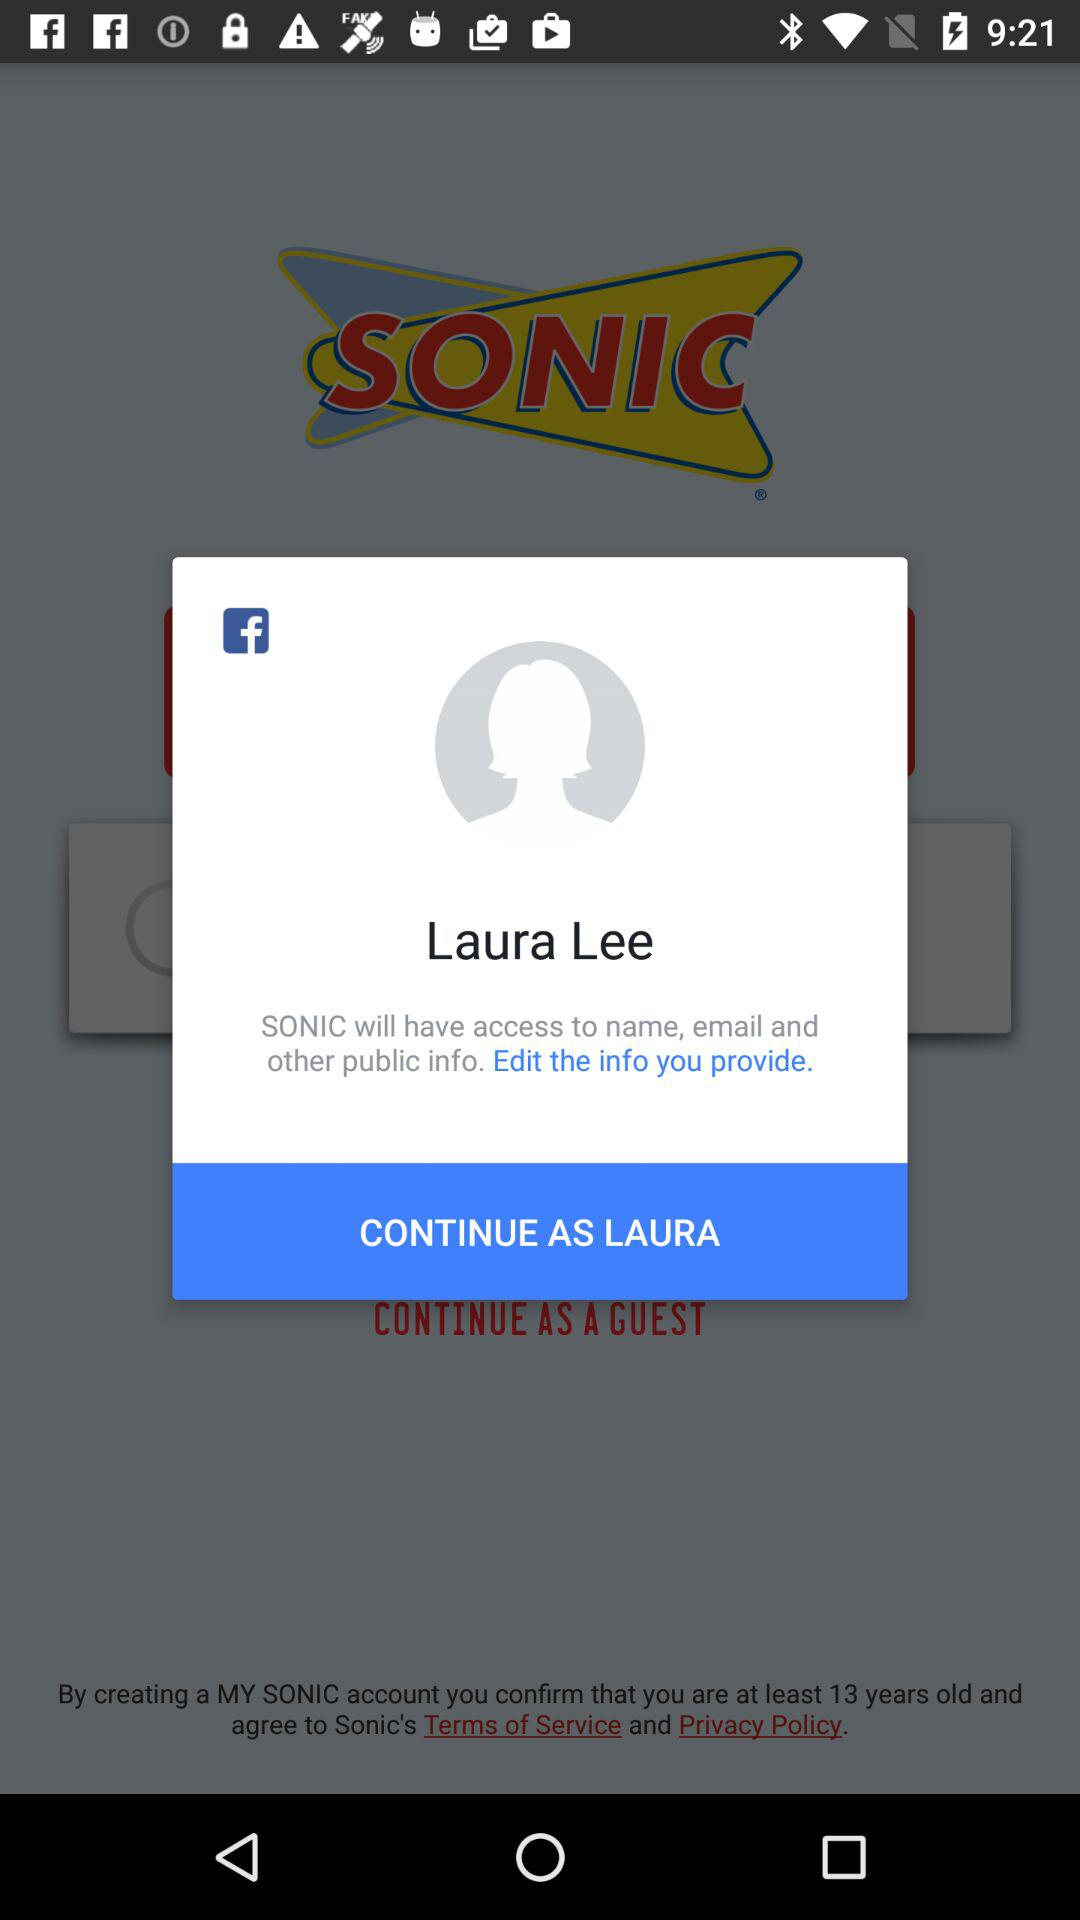What is the user name to continue the profile? The user name is "LAURA". 